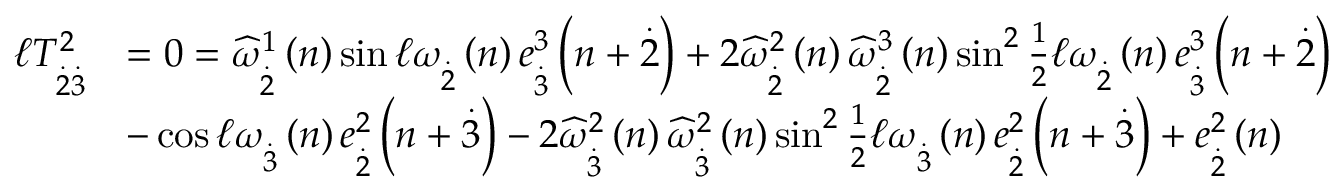<formula> <loc_0><loc_0><loc_500><loc_500>\begin{array} { r l } { \mathcal { \ell } T _ { \overset { . } { 2 } \overset { . } { 3 } } ^ { 2 } } & { = 0 = \widehat { \omega } _ { \overset { . } { 2 } } ^ { 1 } \left ( n \right ) \sin \mathcal { \ell } \omega _ { \overset { . } { 2 } } \left ( n \right ) e _ { \overset { . } { 3 } } ^ { 3 } \left ( n + \overset { . } { 2 } \right ) + 2 \widehat { \omega } _ { \overset { . } { 2 } } ^ { 2 } \left ( n \right ) \widehat { \omega } _ { \overset { . } { 2 } } ^ { 3 } \left ( n \right ) \sin ^ { 2 } \frac { 1 } { 2 } \mathcal { \ell } \omega _ { \overset { . } { 2 } } \left ( n \right ) e _ { \overset { . } { 3 } } ^ { 3 } \left ( n + \overset { . } { 2 } \right ) } \\ & { - \cos \mathcal { \ell } \omega _ { \overset { . } { 3 } } \left ( n \right ) e _ { \overset { . } { 2 } } ^ { 2 } \left ( n + \overset { . } { 3 } \right ) - 2 \widehat { \omega } _ { \overset { . } { 3 } } ^ { 2 } \left ( n \right ) \widehat { \omega } _ { \overset { . } { 3 } } ^ { 2 } \left ( n \right ) \sin ^ { 2 } \frac { 1 } { 2 } \mathcal { \ell } \omega _ { \overset { . } { 3 } } \left ( n \right ) e _ { \overset { . } { 2 } } ^ { 2 } \left ( n + \overset { . } { 3 } \right ) + e _ { \overset { . } { 2 } } ^ { 2 } \left ( n \right ) } \end{array}</formula> 